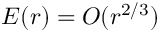<formula> <loc_0><loc_0><loc_500><loc_500>E ( r ) = O ( r ^ { 2 / 3 } )</formula> 